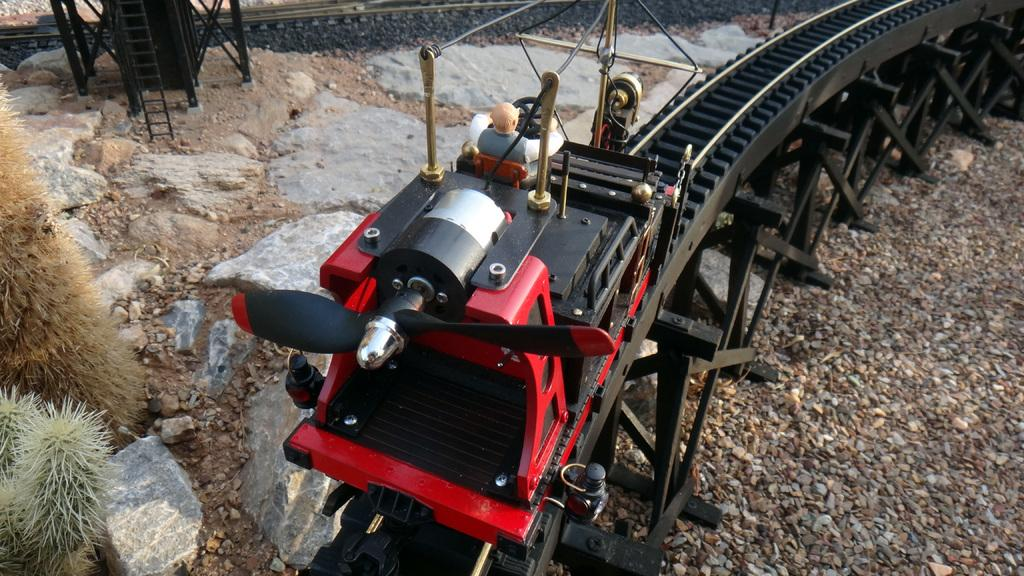What is the main subject of the image? The main subject of the image is a train toy. What is the train toy doing in the image? The train toy is moving on a track. Can you describe the track the train toy is on? The track has pillars. Are there any other objects or elements on the surface in the image? Yes, there are stones placed on the surface. What can be seen on the left side of the image? There are two plants on the left side of the image. What type of lamp is used to control the train toy's movement in the image? There is no lamp or control mechanism present in the image; the train toy is moving on a track without any visible means of control. 